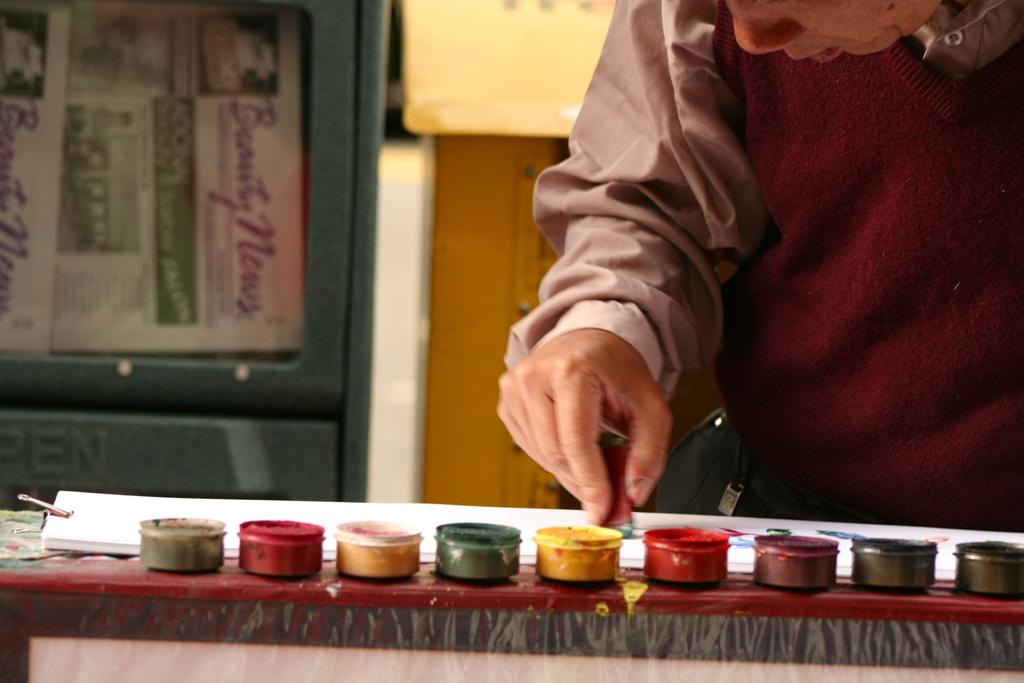What is on the table in the image? There are papers and small plastic boxes on the table. What is inside the small plastic boxes? The small plastic boxes contain colors. Can you describe the objects visible in the background? There are objects visible in the background, but their specific details are not mentioned in the facts. What is the person in the background holding? The person in the background is holding something, but its specific details are not mentioned in the facts. What type of horn can be heard in the image? There is no horn or sound present in the image. Is there a baby visible in the image? There is no mention of a baby in the provided facts, so it cannot be determined if one is present in the image. 